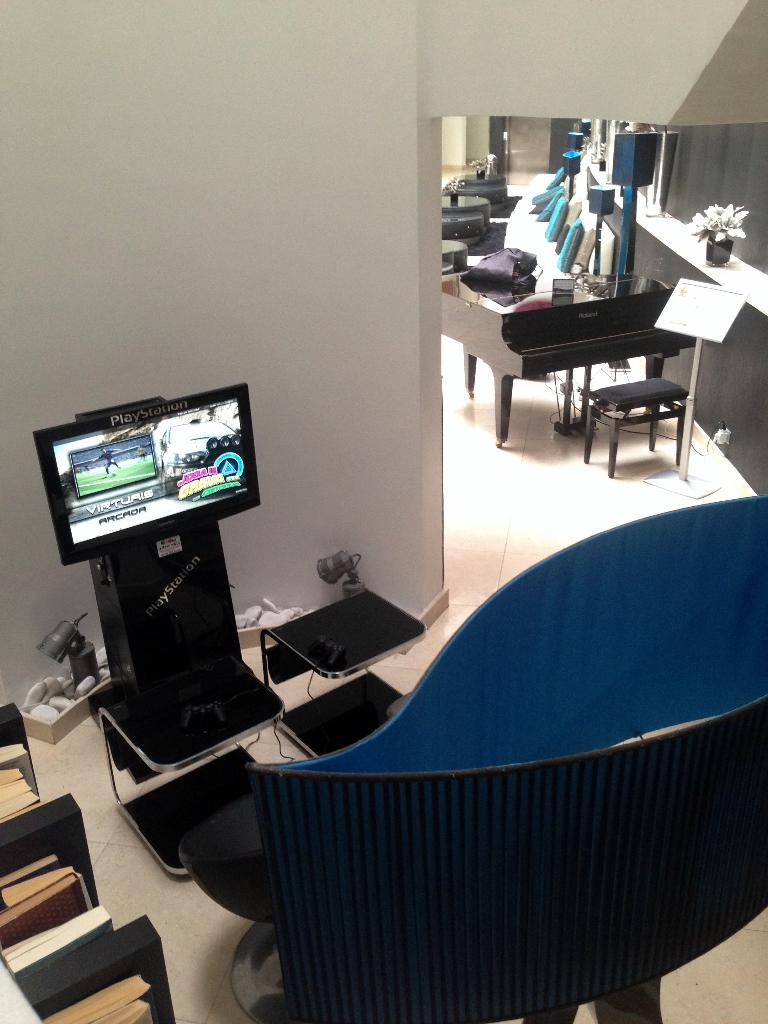What type of furniture is in the image? There is a chair in the image. What is located in front of the chair? There is a television in front of the chair. What items can be seen related to reading or learning? There are books in the image. What is the background of the image made of? There is a wall in the image. What type of decorative item is present in the image? There is a flower pot in the image. What degree does the expert in the image hold? There is no expert present in the image, and therefore no degree can be attributed to anyone. 